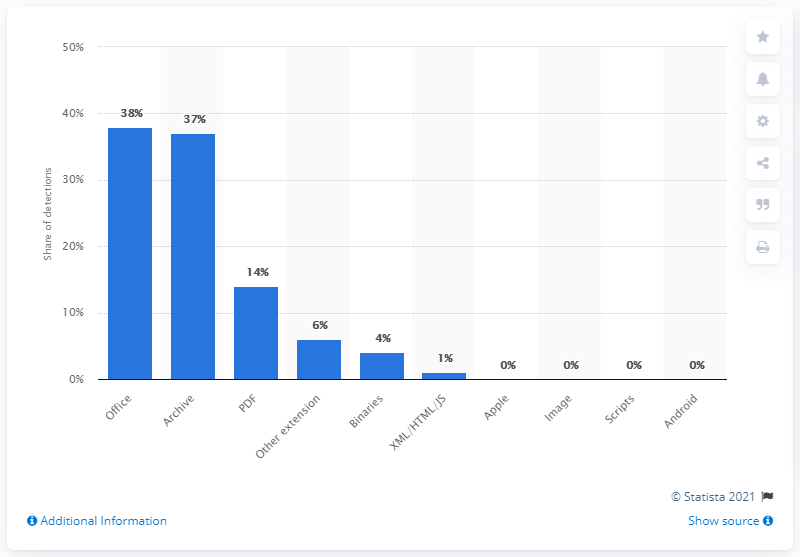Indicate a few pertinent items in this graphic. According to the data, 38% of malware file detections were related to Office files. 